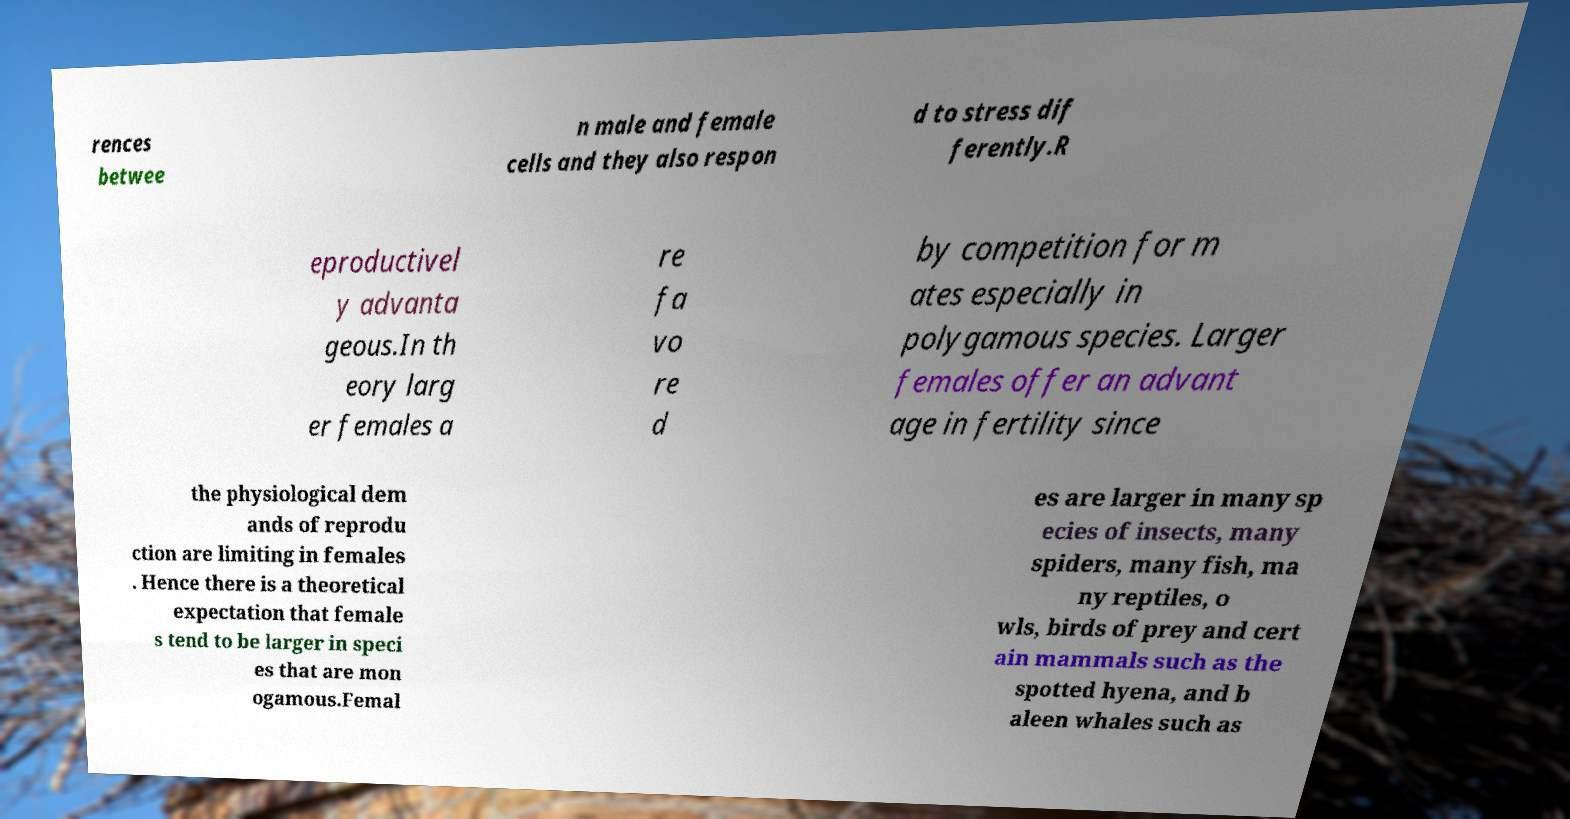Could you extract and type out the text from this image? rences betwee n male and female cells and they also respon d to stress dif ferently.R eproductivel y advanta geous.In th eory larg er females a re fa vo re d by competition for m ates especially in polygamous species. Larger females offer an advant age in fertility since the physiological dem ands of reprodu ction are limiting in females . Hence there is a theoretical expectation that female s tend to be larger in speci es that are mon ogamous.Femal es are larger in many sp ecies of insects, many spiders, many fish, ma ny reptiles, o wls, birds of prey and cert ain mammals such as the spotted hyena, and b aleen whales such as 